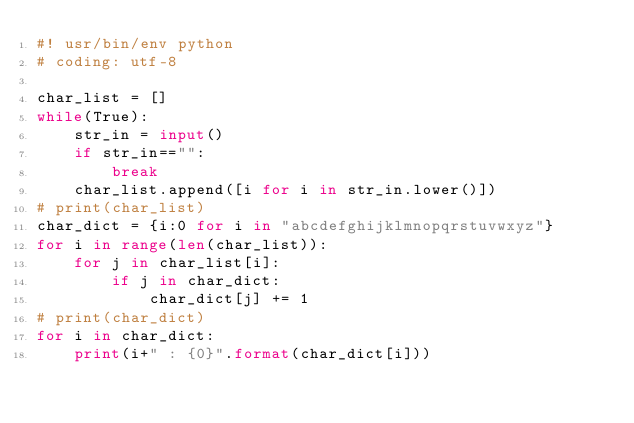Convert code to text. <code><loc_0><loc_0><loc_500><loc_500><_Python_>#! usr/bin/env python
# coding: utf-8

char_list = []
while(True):
    str_in = input()
    if str_in=="":
        break
    char_list.append([i for i in str_in.lower()])
# print(char_list)
char_dict = {i:0 for i in "abcdefghijklmnopqrstuvwxyz"}
for i in range(len(char_list)):
    for j in char_list[i]:
        if j in char_dict:
            char_dict[j] += 1
# print(char_dict)
for i in char_dict:
    print(i+" : {0}".format(char_dict[i]))

</code> 